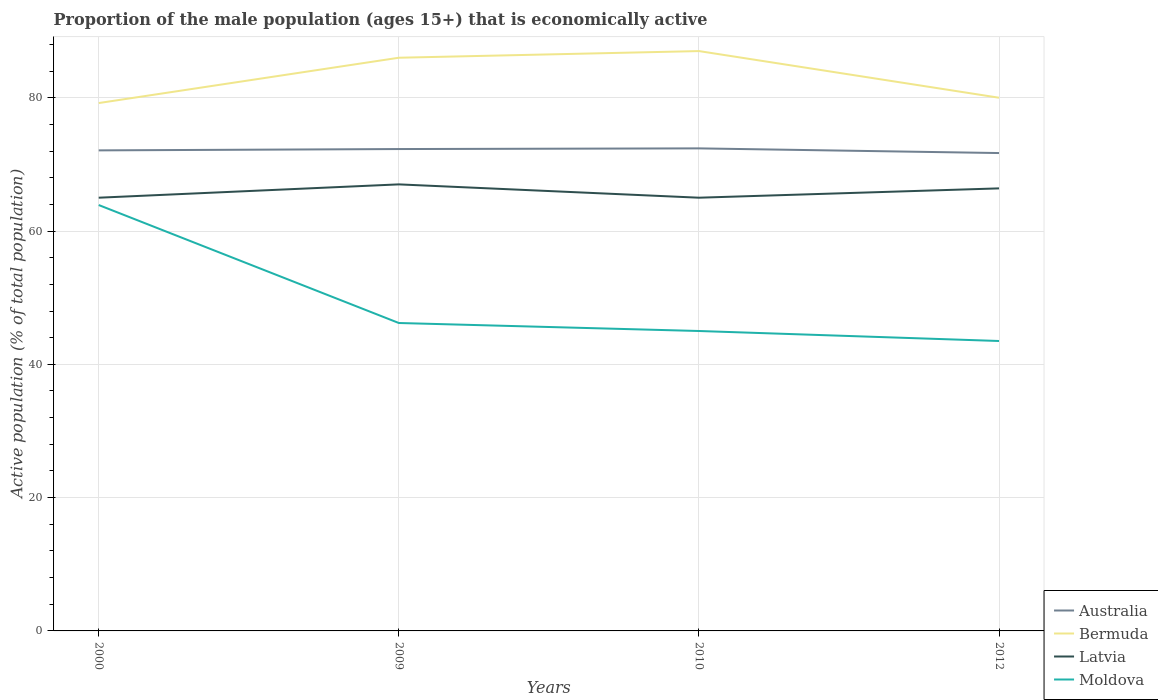Is the number of lines equal to the number of legend labels?
Your response must be concise. Yes. Across all years, what is the maximum proportion of the male population that is economically active in Bermuda?
Your answer should be compact. 79.2. In which year was the proportion of the male population that is economically active in Moldova maximum?
Your answer should be compact. 2012. What is the total proportion of the male population that is economically active in Moldova in the graph?
Offer a very short reply. 2.7. What is the difference between the highest and the second highest proportion of the male population that is economically active in Moldova?
Provide a succinct answer. 20.4. What is the difference between the highest and the lowest proportion of the male population that is economically active in Moldova?
Your answer should be very brief. 1. Is the proportion of the male population that is economically active in Moldova strictly greater than the proportion of the male population that is economically active in Australia over the years?
Your answer should be very brief. Yes. What is the difference between two consecutive major ticks on the Y-axis?
Give a very brief answer. 20. Does the graph contain any zero values?
Give a very brief answer. No. Where does the legend appear in the graph?
Give a very brief answer. Bottom right. How many legend labels are there?
Provide a short and direct response. 4. How are the legend labels stacked?
Offer a very short reply. Vertical. What is the title of the graph?
Your response must be concise. Proportion of the male population (ages 15+) that is economically active. What is the label or title of the X-axis?
Your answer should be very brief. Years. What is the label or title of the Y-axis?
Give a very brief answer. Active population (% of total population). What is the Active population (% of total population) in Australia in 2000?
Give a very brief answer. 72.1. What is the Active population (% of total population) of Bermuda in 2000?
Offer a very short reply. 79.2. What is the Active population (% of total population) of Latvia in 2000?
Ensure brevity in your answer.  65. What is the Active population (% of total population) in Moldova in 2000?
Make the answer very short. 63.9. What is the Active population (% of total population) in Australia in 2009?
Provide a short and direct response. 72.3. What is the Active population (% of total population) of Moldova in 2009?
Provide a short and direct response. 46.2. What is the Active population (% of total population) of Australia in 2010?
Offer a terse response. 72.4. What is the Active population (% of total population) of Bermuda in 2010?
Your response must be concise. 87. What is the Active population (% of total population) of Australia in 2012?
Offer a terse response. 71.7. What is the Active population (% of total population) of Latvia in 2012?
Your answer should be very brief. 66.4. What is the Active population (% of total population) in Moldova in 2012?
Ensure brevity in your answer.  43.5. Across all years, what is the maximum Active population (% of total population) of Australia?
Your answer should be very brief. 72.4. Across all years, what is the maximum Active population (% of total population) in Bermuda?
Your response must be concise. 87. Across all years, what is the maximum Active population (% of total population) in Latvia?
Ensure brevity in your answer.  67. Across all years, what is the maximum Active population (% of total population) of Moldova?
Give a very brief answer. 63.9. Across all years, what is the minimum Active population (% of total population) of Australia?
Give a very brief answer. 71.7. Across all years, what is the minimum Active population (% of total population) in Bermuda?
Ensure brevity in your answer.  79.2. Across all years, what is the minimum Active population (% of total population) of Moldova?
Keep it short and to the point. 43.5. What is the total Active population (% of total population) in Australia in the graph?
Your answer should be very brief. 288.5. What is the total Active population (% of total population) of Bermuda in the graph?
Offer a very short reply. 332.2. What is the total Active population (% of total population) of Latvia in the graph?
Provide a short and direct response. 263.4. What is the total Active population (% of total population) of Moldova in the graph?
Your response must be concise. 198.6. What is the difference between the Active population (% of total population) in Bermuda in 2000 and that in 2010?
Your answer should be compact. -7.8. What is the difference between the Active population (% of total population) of Moldova in 2000 and that in 2010?
Your answer should be very brief. 18.9. What is the difference between the Active population (% of total population) of Bermuda in 2000 and that in 2012?
Provide a short and direct response. -0.8. What is the difference between the Active population (% of total population) of Latvia in 2000 and that in 2012?
Give a very brief answer. -1.4. What is the difference between the Active population (% of total population) of Moldova in 2000 and that in 2012?
Your response must be concise. 20.4. What is the difference between the Active population (% of total population) in Australia in 2009 and that in 2010?
Your response must be concise. -0.1. What is the difference between the Active population (% of total population) in Latvia in 2009 and that in 2010?
Your answer should be compact. 2. What is the difference between the Active population (% of total population) of Moldova in 2009 and that in 2010?
Make the answer very short. 1.2. What is the difference between the Active population (% of total population) of Bermuda in 2009 and that in 2012?
Ensure brevity in your answer.  6. What is the difference between the Active population (% of total population) in Latvia in 2009 and that in 2012?
Offer a very short reply. 0.6. What is the difference between the Active population (% of total population) in Moldova in 2009 and that in 2012?
Provide a short and direct response. 2.7. What is the difference between the Active population (% of total population) of Bermuda in 2010 and that in 2012?
Your answer should be compact. 7. What is the difference between the Active population (% of total population) of Latvia in 2010 and that in 2012?
Make the answer very short. -1.4. What is the difference between the Active population (% of total population) of Moldova in 2010 and that in 2012?
Ensure brevity in your answer.  1.5. What is the difference between the Active population (% of total population) in Australia in 2000 and the Active population (% of total population) in Latvia in 2009?
Keep it short and to the point. 5.1. What is the difference between the Active population (% of total population) in Australia in 2000 and the Active population (% of total population) in Moldova in 2009?
Your response must be concise. 25.9. What is the difference between the Active population (% of total population) in Australia in 2000 and the Active population (% of total population) in Bermuda in 2010?
Make the answer very short. -14.9. What is the difference between the Active population (% of total population) in Australia in 2000 and the Active population (% of total population) in Moldova in 2010?
Provide a succinct answer. 27.1. What is the difference between the Active population (% of total population) of Bermuda in 2000 and the Active population (% of total population) of Latvia in 2010?
Your answer should be very brief. 14.2. What is the difference between the Active population (% of total population) of Bermuda in 2000 and the Active population (% of total population) of Moldova in 2010?
Your answer should be compact. 34.2. What is the difference between the Active population (% of total population) of Australia in 2000 and the Active population (% of total population) of Latvia in 2012?
Ensure brevity in your answer.  5.7. What is the difference between the Active population (% of total population) in Australia in 2000 and the Active population (% of total population) in Moldova in 2012?
Give a very brief answer. 28.6. What is the difference between the Active population (% of total population) in Bermuda in 2000 and the Active population (% of total population) in Latvia in 2012?
Keep it short and to the point. 12.8. What is the difference between the Active population (% of total population) of Bermuda in 2000 and the Active population (% of total population) of Moldova in 2012?
Your response must be concise. 35.7. What is the difference between the Active population (% of total population) of Latvia in 2000 and the Active population (% of total population) of Moldova in 2012?
Provide a short and direct response. 21.5. What is the difference between the Active population (% of total population) of Australia in 2009 and the Active population (% of total population) of Bermuda in 2010?
Your answer should be compact. -14.7. What is the difference between the Active population (% of total population) in Australia in 2009 and the Active population (% of total population) in Latvia in 2010?
Your answer should be very brief. 7.3. What is the difference between the Active population (% of total population) of Australia in 2009 and the Active population (% of total population) of Moldova in 2010?
Ensure brevity in your answer.  27.3. What is the difference between the Active population (% of total population) of Bermuda in 2009 and the Active population (% of total population) of Latvia in 2010?
Provide a short and direct response. 21. What is the difference between the Active population (% of total population) of Australia in 2009 and the Active population (% of total population) of Bermuda in 2012?
Provide a succinct answer. -7.7. What is the difference between the Active population (% of total population) of Australia in 2009 and the Active population (% of total population) of Latvia in 2012?
Keep it short and to the point. 5.9. What is the difference between the Active population (% of total population) in Australia in 2009 and the Active population (% of total population) in Moldova in 2012?
Provide a short and direct response. 28.8. What is the difference between the Active population (% of total population) in Bermuda in 2009 and the Active population (% of total population) in Latvia in 2012?
Give a very brief answer. 19.6. What is the difference between the Active population (% of total population) of Bermuda in 2009 and the Active population (% of total population) of Moldova in 2012?
Give a very brief answer. 42.5. What is the difference between the Active population (% of total population) of Australia in 2010 and the Active population (% of total population) of Bermuda in 2012?
Your answer should be compact. -7.6. What is the difference between the Active population (% of total population) in Australia in 2010 and the Active population (% of total population) in Latvia in 2012?
Offer a terse response. 6. What is the difference between the Active population (% of total population) of Australia in 2010 and the Active population (% of total population) of Moldova in 2012?
Offer a very short reply. 28.9. What is the difference between the Active population (% of total population) in Bermuda in 2010 and the Active population (% of total population) in Latvia in 2012?
Your response must be concise. 20.6. What is the difference between the Active population (% of total population) of Bermuda in 2010 and the Active population (% of total population) of Moldova in 2012?
Give a very brief answer. 43.5. What is the difference between the Active population (% of total population) in Latvia in 2010 and the Active population (% of total population) in Moldova in 2012?
Offer a very short reply. 21.5. What is the average Active population (% of total population) in Australia per year?
Provide a short and direct response. 72.12. What is the average Active population (% of total population) in Bermuda per year?
Keep it short and to the point. 83.05. What is the average Active population (% of total population) of Latvia per year?
Your response must be concise. 65.85. What is the average Active population (% of total population) in Moldova per year?
Provide a short and direct response. 49.65. In the year 2000, what is the difference between the Active population (% of total population) in Australia and Active population (% of total population) in Latvia?
Offer a terse response. 7.1. In the year 2000, what is the difference between the Active population (% of total population) of Australia and Active population (% of total population) of Moldova?
Offer a terse response. 8.2. In the year 2000, what is the difference between the Active population (% of total population) of Bermuda and Active population (% of total population) of Moldova?
Keep it short and to the point. 15.3. In the year 2000, what is the difference between the Active population (% of total population) in Latvia and Active population (% of total population) in Moldova?
Provide a succinct answer. 1.1. In the year 2009, what is the difference between the Active population (% of total population) of Australia and Active population (% of total population) of Bermuda?
Provide a short and direct response. -13.7. In the year 2009, what is the difference between the Active population (% of total population) in Australia and Active population (% of total population) in Latvia?
Offer a terse response. 5.3. In the year 2009, what is the difference between the Active population (% of total population) in Australia and Active population (% of total population) in Moldova?
Provide a succinct answer. 26.1. In the year 2009, what is the difference between the Active population (% of total population) of Bermuda and Active population (% of total population) of Moldova?
Ensure brevity in your answer.  39.8. In the year 2009, what is the difference between the Active population (% of total population) in Latvia and Active population (% of total population) in Moldova?
Provide a short and direct response. 20.8. In the year 2010, what is the difference between the Active population (% of total population) of Australia and Active population (% of total population) of Bermuda?
Give a very brief answer. -14.6. In the year 2010, what is the difference between the Active population (% of total population) of Australia and Active population (% of total population) of Latvia?
Offer a very short reply. 7.4. In the year 2010, what is the difference between the Active population (% of total population) in Australia and Active population (% of total population) in Moldova?
Provide a short and direct response. 27.4. In the year 2010, what is the difference between the Active population (% of total population) in Bermuda and Active population (% of total population) in Latvia?
Offer a terse response. 22. In the year 2010, what is the difference between the Active population (% of total population) of Bermuda and Active population (% of total population) of Moldova?
Make the answer very short. 42. In the year 2010, what is the difference between the Active population (% of total population) of Latvia and Active population (% of total population) of Moldova?
Keep it short and to the point. 20. In the year 2012, what is the difference between the Active population (% of total population) in Australia and Active population (% of total population) in Latvia?
Provide a short and direct response. 5.3. In the year 2012, what is the difference between the Active population (% of total population) in Australia and Active population (% of total population) in Moldova?
Ensure brevity in your answer.  28.2. In the year 2012, what is the difference between the Active population (% of total population) in Bermuda and Active population (% of total population) in Latvia?
Provide a short and direct response. 13.6. In the year 2012, what is the difference between the Active population (% of total population) of Bermuda and Active population (% of total population) of Moldova?
Your response must be concise. 36.5. In the year 2012, what is the difference between the Active population (% of total population) of Latvia and Active population (% of total population) of Moldova?
Provide a short and direct response. 22.9. What is the ratio of the Active population (% of total population) in Bermuda in 2000 to that in 2009?
Give a very brief answer. 0.92. What is the ratio of the Active population (% of total population) in Latvia in 2000 to that in 2009?
Give a very brief answer. 0.97. What is the ratio of the Active population (% of total population) of Moldova in 2000 to that in 2009?
Your answer should be very brief. 1.38. What is the ratio of the Active population (% of total population) in Australia in 2000 to that in 2010?
Provide a short and direct response. 1. What is the ratio of the Active population (% of total population) of Bermuda in 2000 to that in 2010?
Provide a short and direct response. 0.91. What is the ratio of the Active population (% of total population) in Moldova in 2000 to that in 2010?
Your answer should be compact. 1.42. What is the ratio of the Active population (% of total population) of Australia in 2000 to that in 2012?
Ensure brevity in your answer.  1.01. What is the ratio of the Active population (% of total population) of Bermuda in 2000 to that in 2012?
Provide a succinct answer. 0.99. What is the ratio of the Active population (% of total population) of Latvia in 2000 to that in 2012?
Provide a short and direct response. 0.98. What is the ratio of the Active population (% of total population) in Moldova in 2000 to that in 2012?
Provide a succinct answer. 1.47. What is the ratio of the Active population (% of total population) of Bermuda in 2009 to that in 2010?
Offer a terse response. 0.99. What is the ratio of the Active population (% of total population) of Latvia in 2009 to that in 2010?
Keep it short and to the point. 1.03. What is the ratio of the Active population (% of total population) in Moldova in 2009 to that in 2010?
Your answer should be compact. 1.03. What is the ratio of the Active population (% of total population) of Australia in 2009 to that in 2012?
Offer a very short reply. 1.01. What is the ratio of the Active population (% of total population) of Bermuda in 2009 to that in 2012?
Your answer should be compact. 1.07. What is the ratio of the Active population (% of total population) in Latvia in 2009 to that in 2012?
Give a very brief answer. 1.01. What is the ratio of the Active population (% of total population) in Moldova in 2009 to that in 2012?
Offer a terse response. 1.06. What is the ratio of the Active population (% of total population) of Australia in 2010 to that in 2012?
Your answer should be compact. 1.01. What is the ratio of the Active population (% of total population) in Bermuda in 2010 to that in 2012?
Your answer should be compact. 1.09. What is the ratio of the Active population (% of total population) in Latvia in 2010 to that in 2012?
Keep it short and to the point. 0.98. What is the ratio of the Active population (% of total population) of Moldova in 2010 to that in 2012?
Offer a terse response. 1.03. What is the difference between the highest and the second highest Active population (% of total population) in Australia?
Ensure brevity in your answer.  0.1. What is the difference between the highest and the second highest Active population (% of total population) of Bermuda?
Provide a short and direct response. 1. What is the difference between the highest and the second highest Active population (% of total population) of Latvia?
Your answer should be very brief. 0.6. What is the difference between the highest and the lowest Active population (% of total population) in Moldova?
Make the answer very short. 20.4. 